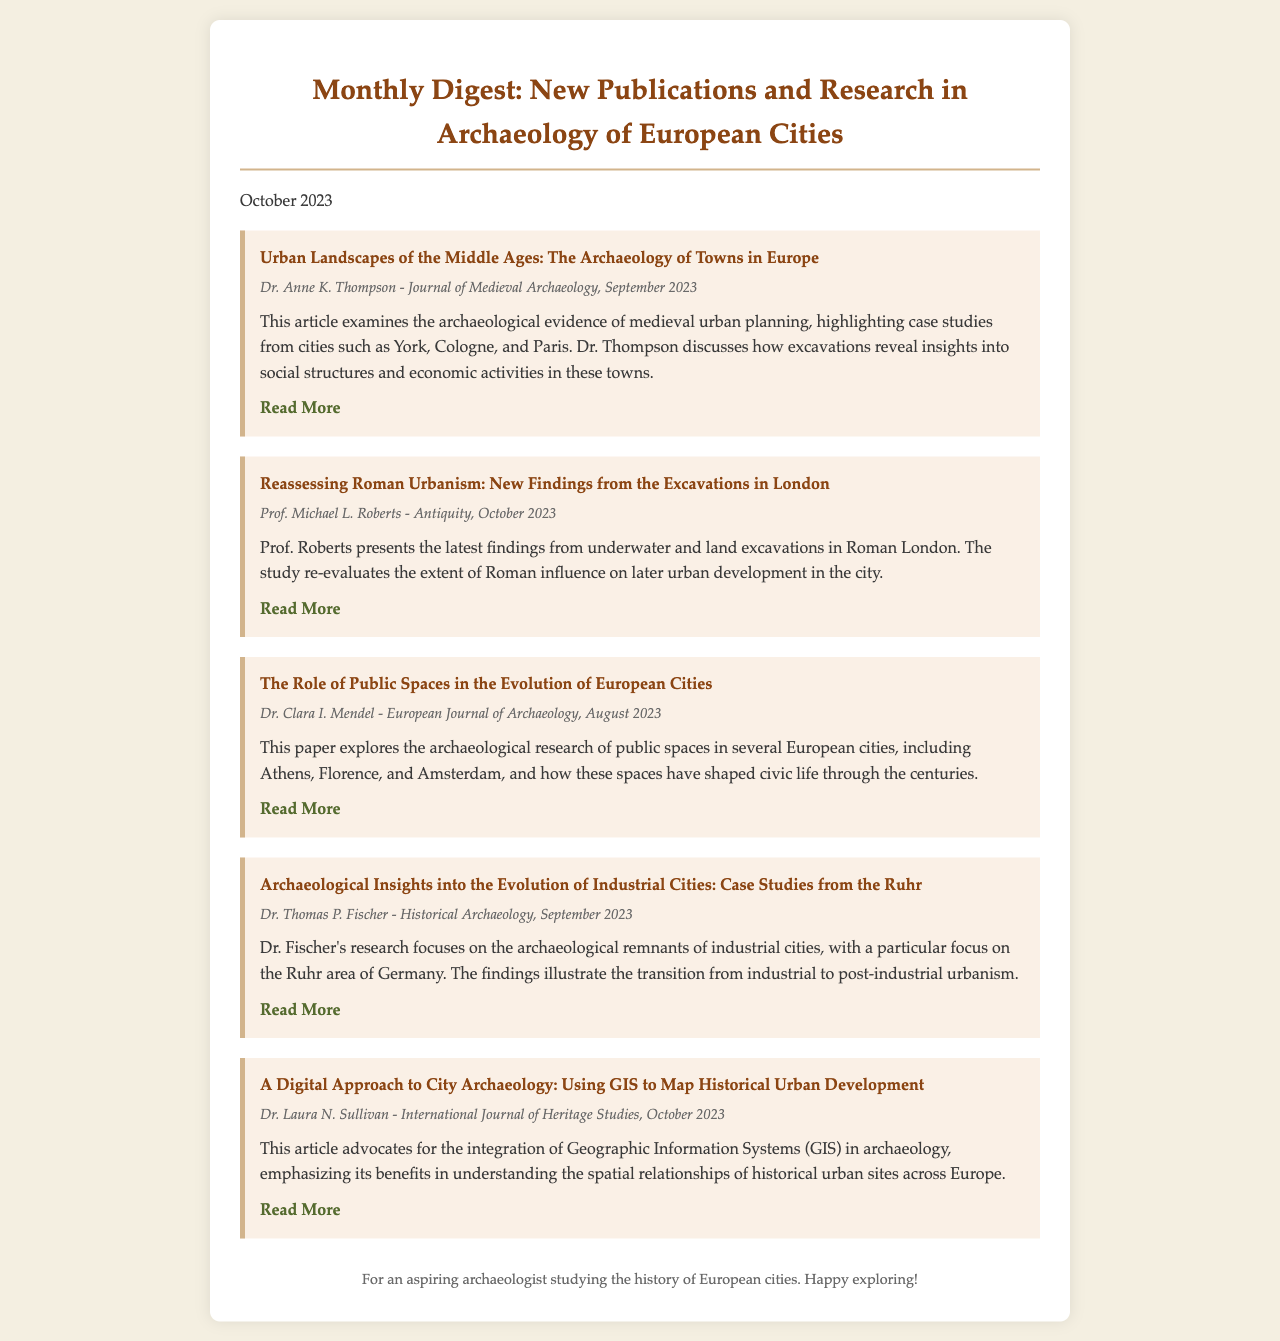What is the title of the first article? The title of the first article is "Urban Landscapes of the Middle Ages: The Archaeology of Towns in Europe."
Answer: Urban Landscapes of the Middle Ages: The Archaeology of Towns in Europe Who authored the article on Roman Urbanism? The author of the article on Roman Urbanism is Prof. Michael L. Roberts.
Answer: Prof. Michael L. Roberts What is the publication month of the article on public spaces? The article on public spaces was published in August 2023.
Answer: August 2023 How many articles are listed in the digest? There are five articles listed in the digest.
Answer: Five What archaeological area does Dr. Thomas P. Fischer focus on in his research? Dr. Thomas P. Fischer focuses on the Ruhr area in his research on industrial cities.
Answer: Ruhr Which article advocates for the use of GIS in archaeology? The article titled "A Digital Approach to City Archaeology: Using GIS to Map Historical Urban Development" advocates for the use of GIS.
Answer: A Digital Approach to City Archaeology: Using GIS to Map Historical Urban Development Who is the intended audience for this monthly digest? The intended audience for this monthly digest is aspiring archaeologists studying the history of European cities.
Answer: Aspiring archaeologists In which journal was the article by Dr. Anne K. Thompson published? The article by Dr. Anne K. Thompson was published in the Journal of Medieval Archaeology.
Answer: Journal of Medieval Archaeology 